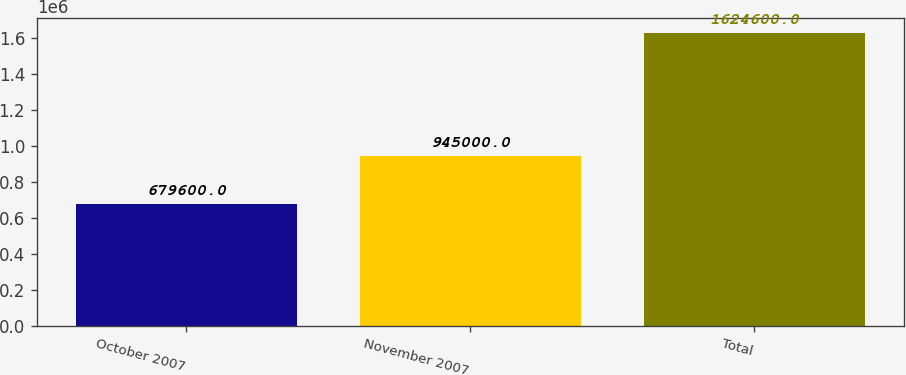Convert chart to OTSL. <chart><loc_0><loc_0><loc_500><loc_500><bar_chart><fcel>October 2007<fcel>November 2007<fcel>Total<nl><fcel>679600<fcel>945000<fcel>1.6246e+06<nl></chart> 